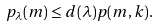<formula> <loc_0><loc_0><loc_500><loc_500>p _ { \lambda } ( m ) \leq d ( \lambda ) p ( m , k ) .</formula> 